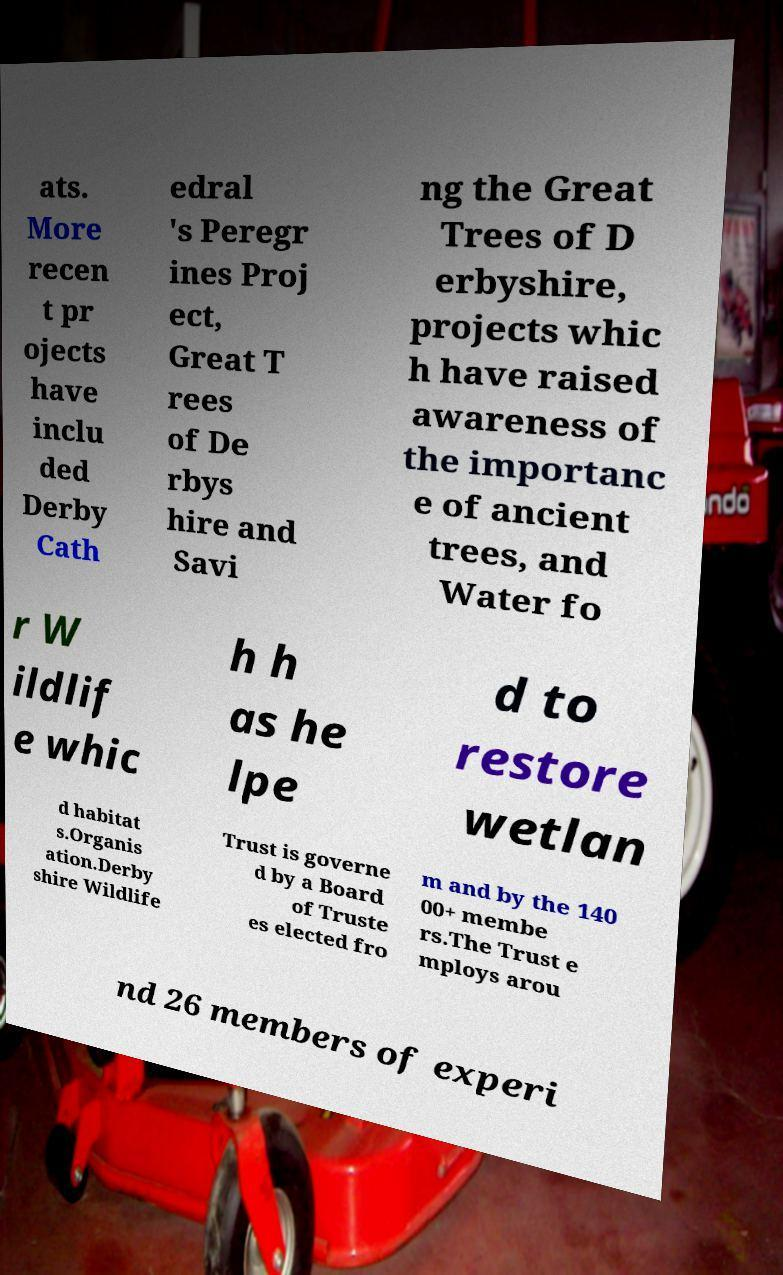Could you assist in decoding the text presented in this image and type it out clearly? ats. More recen t pr ojects have inclu ded Derby Cath edral 's Peregr ines Proj ect, Great T rees of De rbys hire and Savi ng the Great Trees of D erbyshire, projects whic h have raised awareness of the importanc e of ancient trees, and Water fo r W ildlif e whic h h as he lpe d to restore wetlan d habitat s.Organis ation.Derby shire Wildlife Trust is governe d by a Board of Truste es elected fro m and by the 140 00+ membe rs.The Trust e mploys arou nd 26 members of experi 